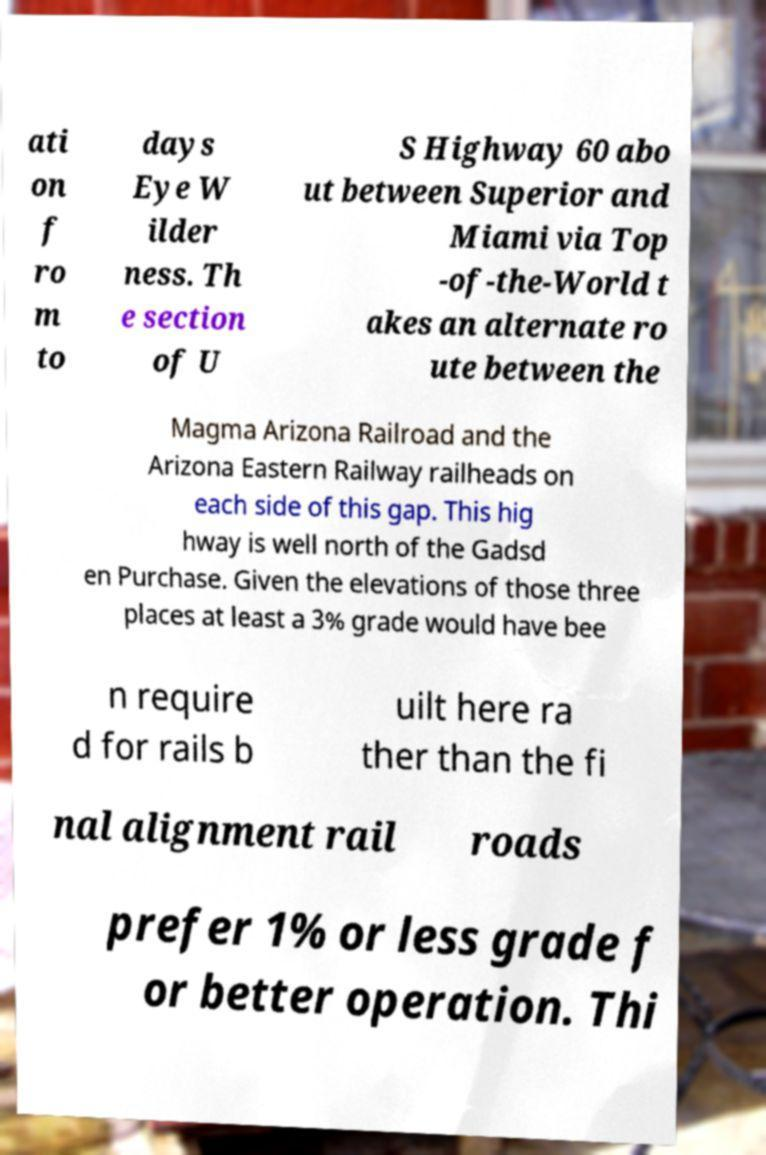Please read and relay the text visible in this image. What does it say? ati on f ro m to days Eye W ilder ness. Th e section of U S Highway 60 abo ut between Superior and Miami via Top -of-the-World t akes an alternate ro ute between the Magma Arizona Railroad and the Arizona Eastern Railway railheads on each side of this gap. This hig hway is well north of the Gadsd en Purchase. Given the elevations of those three places at least a 3% grade would have bee n require d for rails b uilt here ra ther than the fi nal alignment rail roads prefer 1% or less grade f or better operation. Thi 